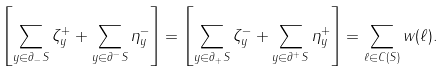<formula> <loc_0><loc_0><loc_500><loc_500>\left [ \sum _ { y \in \partial _ { - } S } \zeta _ { y } ^ { + } + \sum _ { y \in \partial ^ { - } S } \eta _ { y } ^ { - } \right ] = \left [ \sum _ { y \in \partial _ { + } S } \zeta _ { y } ^ { - } + \sum _ { y \in \partial ^ { + } S } \eta _ { y } ^ { + } \right ] = \sum _ { \ell \in C ( S ) } w ( \ell ) .</formula> 